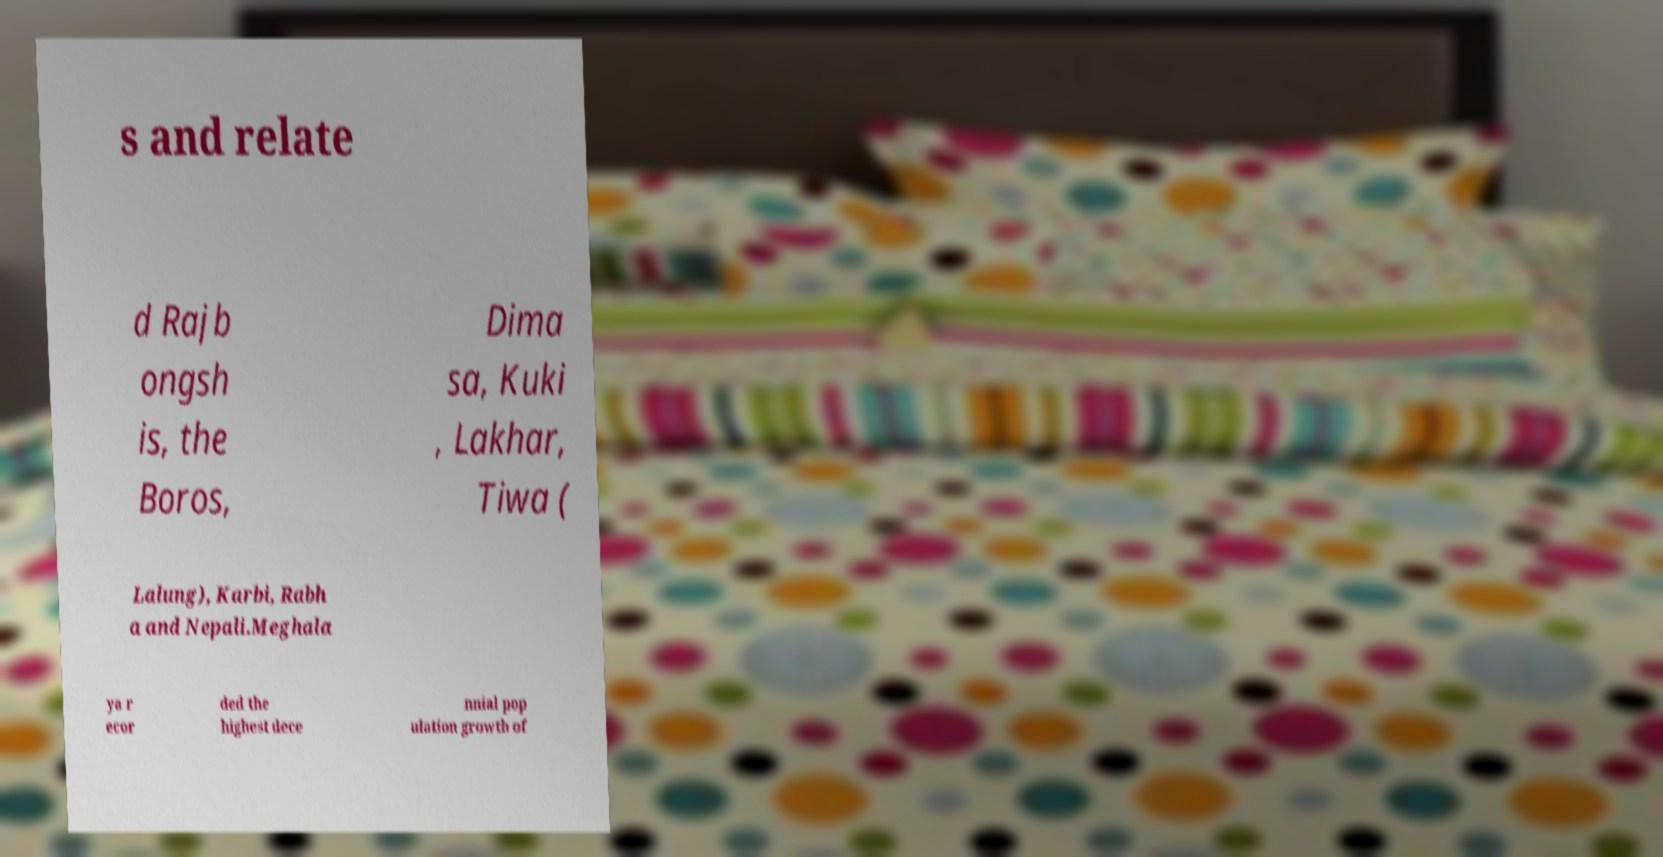Could you extract and type out the text from this image? s and relate d Rajb ongsh is, the Boros, Dima sa, Kuki , Lakhar, Tiwa ( Lalung), Karbi, Rabh a and Nepali.Meghala ya r ecor ded the highest dece nnial pop ulation growth of 